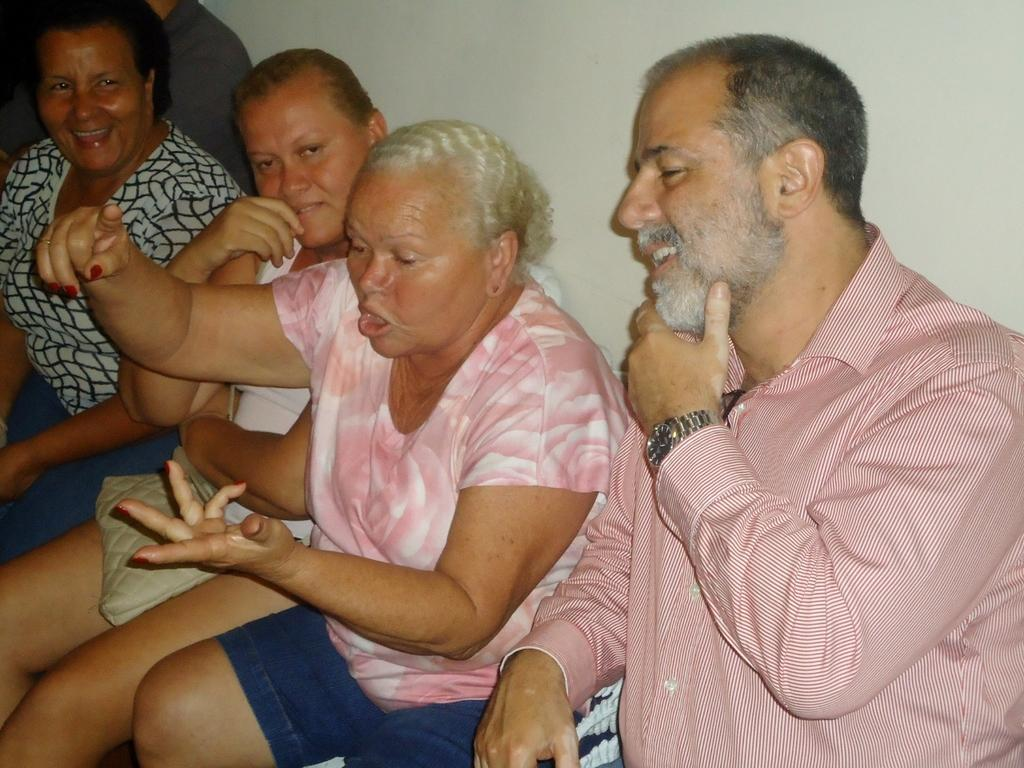What are the people in the image doing? The people in the image are sitting and smiling. Can you describe the people's expressions in the image? The people are smiling in the image. What is visible in the background of the image? There is a wall in the background of the image. How many marks can be seen on the person's arm in the image? There are no marks visible on anyone's arm in the image. What type of finger is being used to point at the wall in the image? There is no finger pointing at the wall in the image; the people are simply sitting and smiling. 